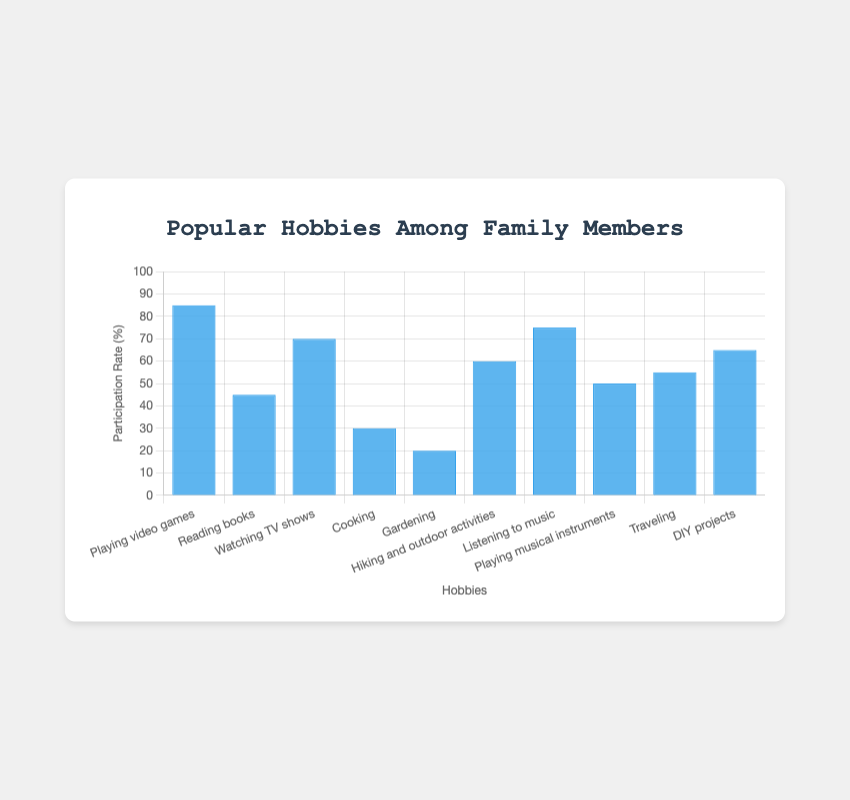Which hobby has the highest participation rate among brothers? Looking at the bar heights in the "Brother" category, the tallest bar corresponds to "Playing video games" with a participation rate of 85%.
Answer: Playing video games What is the difference in participation rates between brothers and sisters for "Gardening"? The participation rate for brothers in "Gardening" is 20%, while for sisters, it is 45%. The difference is 45% - 20% = 25%.
Answer: 25% Which family member has the lowest participation rate in "Listening to music"? By comparing the bar heights for each family member in "Listening to music," the shortest bar is for the father with a participation rate of 60%.
Answer: Father How many hobbies have a brother's participation rate above 50%? Identifying the bars taller than 50% in the "Brother" category, there are 6 hobbies: Playing video games, Watching TV shows, Listening to music, Hiking and outdoor activities, Traveling, and DIY projects.
Answer: 6 What is the average participation rate for brothers in "Cooking" and "Reading books"? The brother's participation rates are 30% for Cooking and 45% for Reading books. The average is (30% + 45%) / 2 = 37.5%.
Answer: 37.5% Which hobby shows the closest participation rates between brothers and sisters? Comparing the bars for brothers and sisters, "Hiking and outdoor activities" has participation rates of 60% for brothers and 65% for sisters, with a small difference of 5%.
Answer: Hiking and outdoor activities Are there any hobbies where the participation rate is equal between brothers and fathers? By comparing the bar lengths for brothers and fathers in each hobby, there are no hobbies where their participation rates are equal.
Answer: No What is the combined participation rate of brothers and sisters for "Playing musical instruments"? The participation rates for brothers and sisters in "Playing musical instruments" are 50% and 65%, respectively. The combined rate is 50% + 65% = 115%.
Answer: 115% Which hobby has the largest range of participation rates among family members? The hobby "Cooking" has the largest range with rates of 30% for brothers, 55% for sisters, 95% for mothers, and 65% for fathers. The range is 95% - 30% = 65%.
Answer: Cooking How much higher is the participation rate for brothers in "Playing video games" compared to fathers in the same hobby? The participation rates are 85% for brothers and 25% for fathers in "Playing video games." The difference is 85% - 25% = 60%.
Answer: 60% 